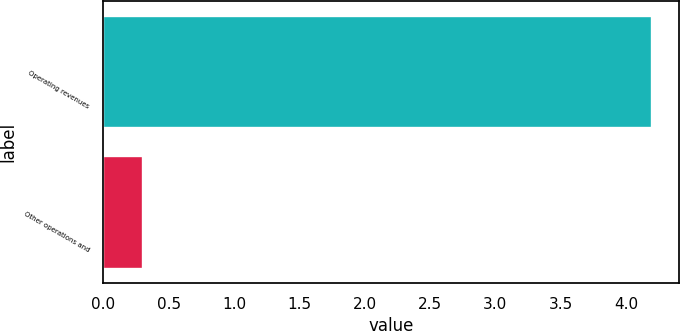Convert chart. <chart><loc_0><loc_0><loc_500><loc_500><bar_chart><fcel>Operating revenues<fcel>Other operations and<nl><fcel>4.2<fcel>0.3<nl></chart> 